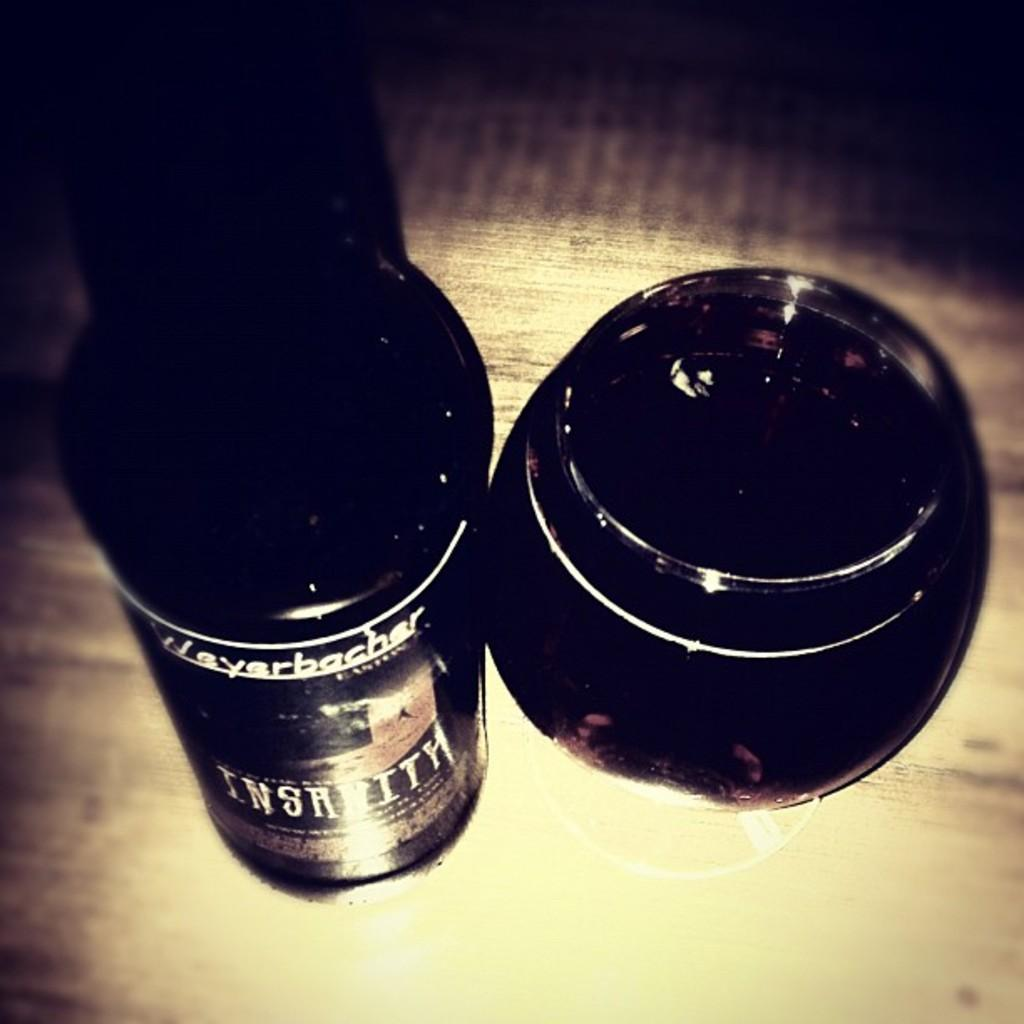What objects are in the image? There are shoe polishers in the image. Where are the shoe polishers located? The shoe polishers are placed on a table. What type of yam is being used to polish the shoes in the image? There is no yam present in the image; the shoe polishers are used for polishing shoes. 